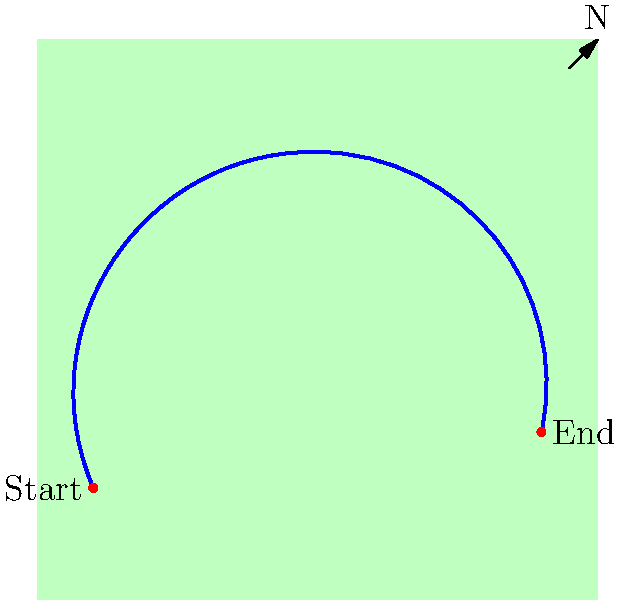Look at the map showing an airplane's flight path. If the plane starts at the red dot on the left and follows the blue line, in which general direction is it traveling? Let's follow the flight path step-by-step:

1. The plane starts at the red dot on the left side of the map.
2. The blue line represents the flight path.
3. As we trace the line from left to right:
   - It first moves upward and to the right (northeast).
   - Then it curves and moves downward and to the right (southeast).
4. Overall, the plane is moving from the left side of the map to the right side.
5. On a world map, moving from left to right generally represents moving from west to east.
6. The compass in the top-right corner confirms that the right side of the map is eastward.

Therefore, the general direction of travel is eastward.
Answer: East 